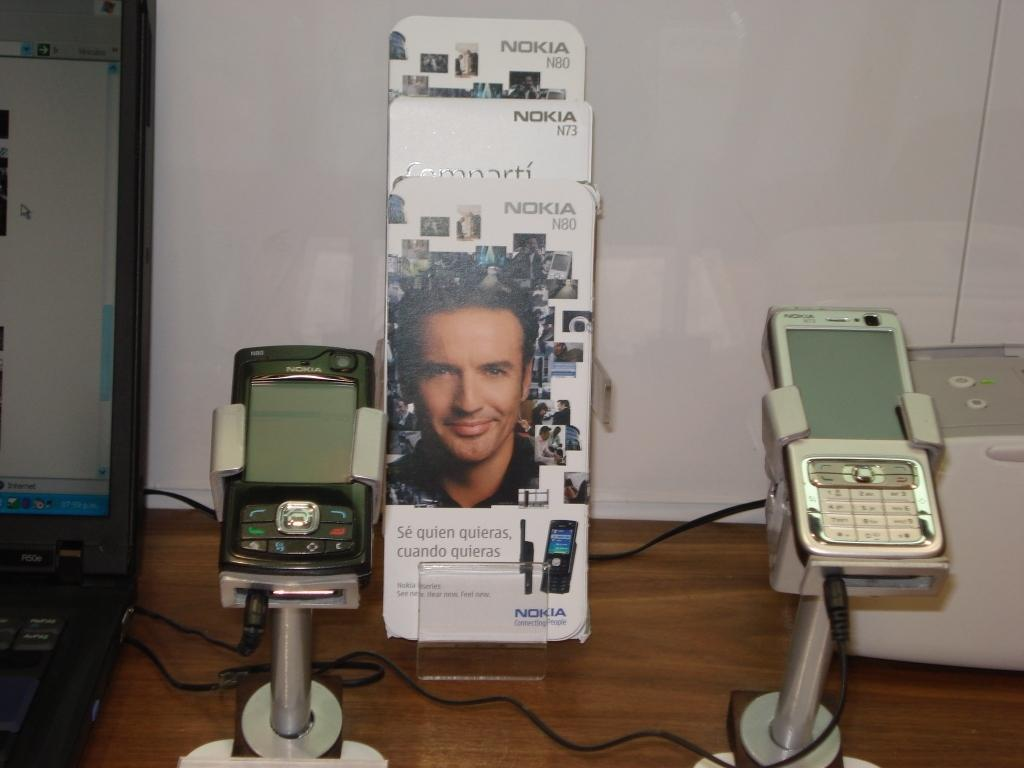What electronic device is visible in the image? There is a laptop in the image. What other electronic devices can be seen in the image? There are mobiles with stands in the image. What type of writing or display surface is present in the image? There are boards in the image. What object is placed on the table in the image? There is an object on the table in the image, but the specific object is not mentioned in the provided facts. Can you see a basin in the image? There is no mention of a basin in the provided facts, so it cannot be determined if one is present in the image. What type of truck is visible in the image? There is no mention of a truck in the provided facts, so it cannot be determined if one is present in the image. 